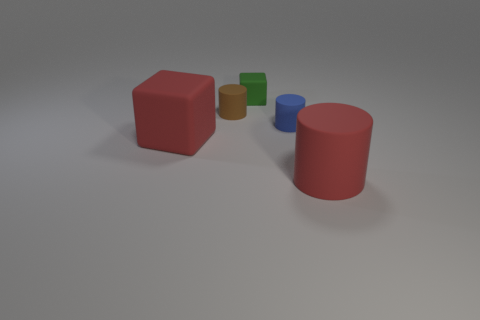Add 3 tiny blue things. How many objects exist? 8 Subtract all cylinders. How many objects are left? 2 Subtract all small brown matte objects. Subtract all tiny green matte objects. How many objects are left? 3 Add 4 large red rubber cubes. How many large red rubber cubes are left? 5 Add 5 tiny blue things. How many tiny blue things exist? 6 Subtract 0 purple balls. How many objects are left? 5 